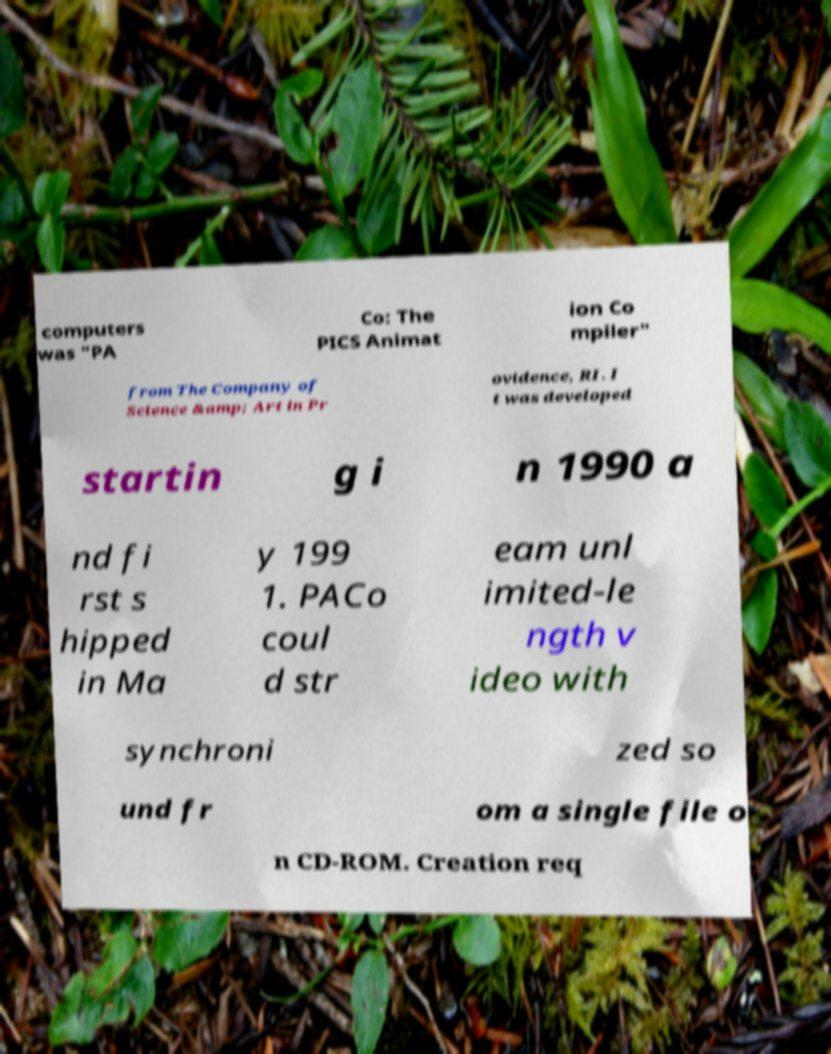What messages or text are displayed in this image? I need them in a readable, typed format. computers was "PA Co: The PICS Animat ion Co mpiler" from The Company of Science &amp; Art in Pr ovidence, RI. I t was developed startin g i n 1990 a nd fi rst s hipped in Ma y 199 1. PACo coul d str eam unl imited-le ngth v ideo with synchroni zed so und fr om a single file o n CD-ROM. Creation req 